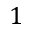Convert formula to latex. <formula><loc_0><loc_0><loc_500><loc_500>1</formula> 